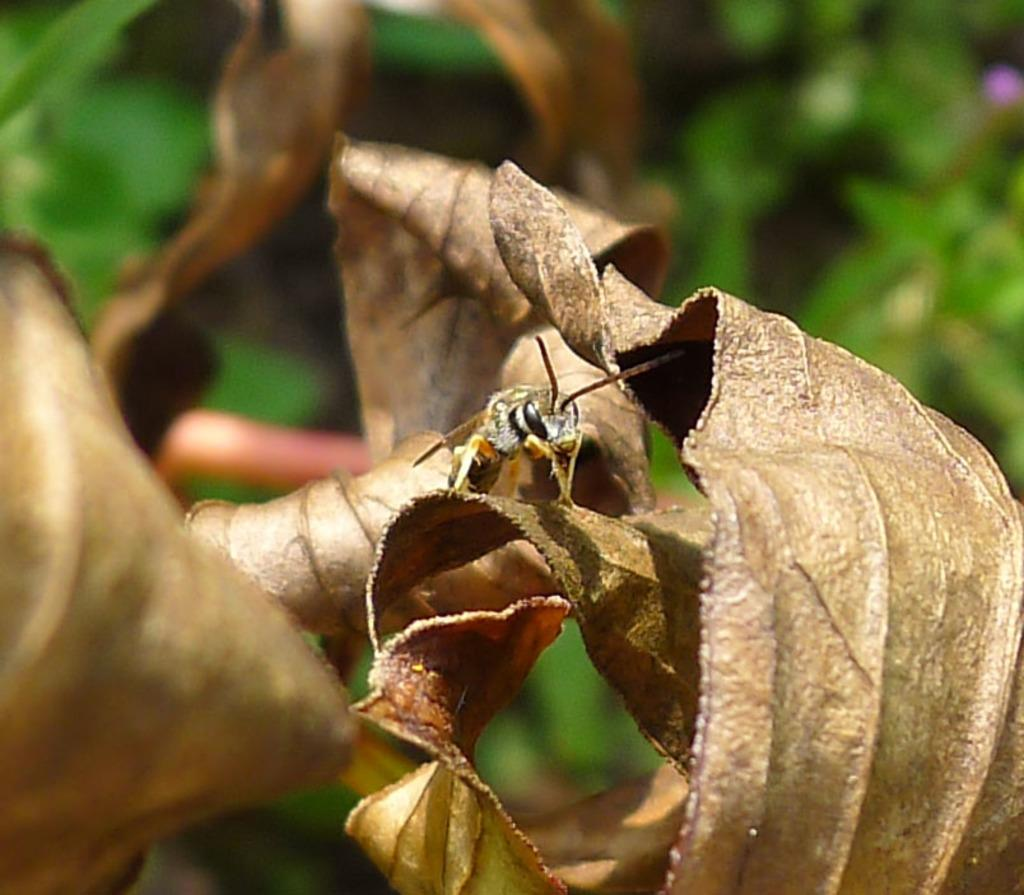What is the main subject of the picture? The main subject of the picture is an insect. Where is the insect located in the image? The insect is on dried leaves. What can be seen in the background of the image? There is greenery in the background of the image. What type of country is depicted in the image? There is no country depicted in the image; it features an insect on dried leaves with greenery in the background. How much debt is associated with the insect in the image? There is no mention of debt in the image; it focuses on an insect and its surroundings. 